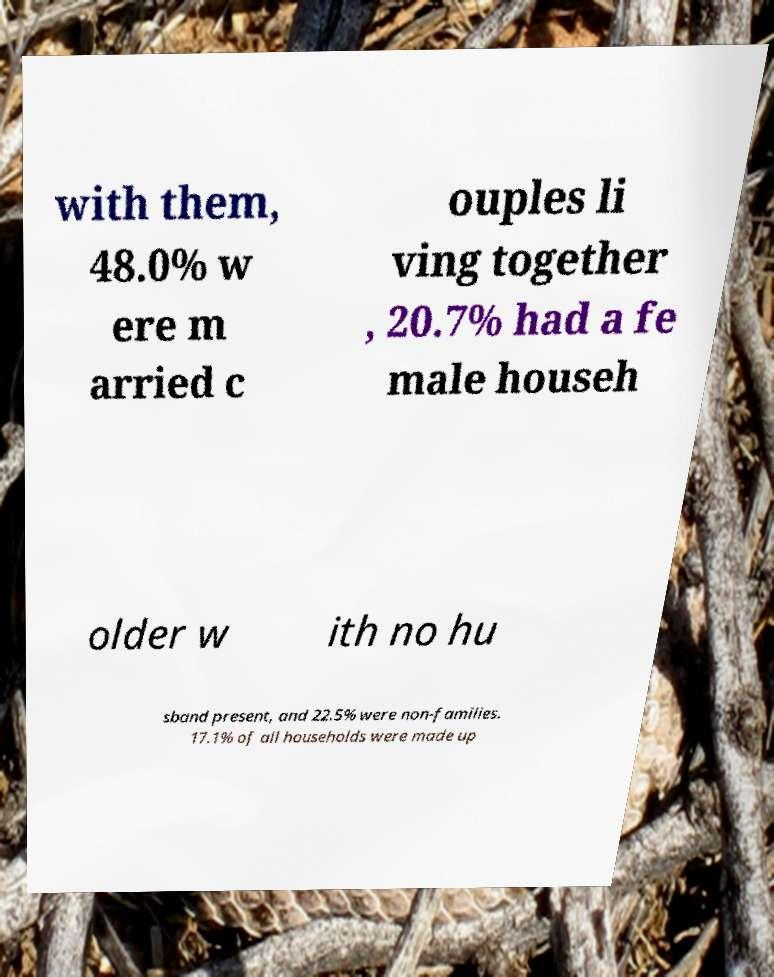Could you extract and type out the text from this image? with them, 48.0% w ere m arried c ouples li ving together , 20.7% had a fe male househ older w ith no hu sband present, and 22.5% were non-families. 17.1% of all households were made up 